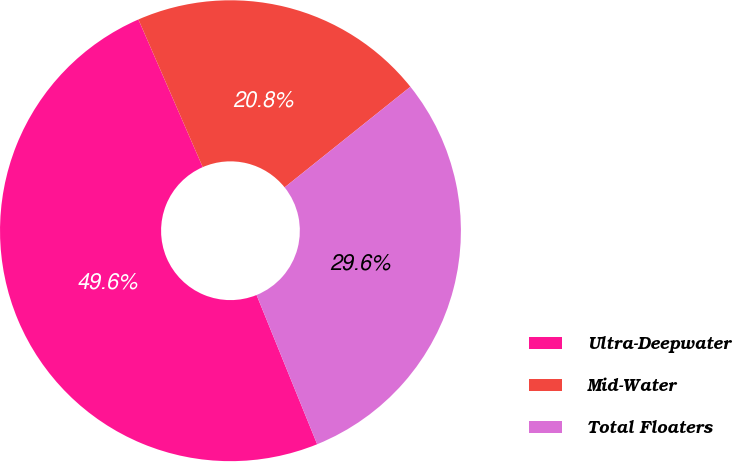Convert chart to OTSL. <chart><loc_0><loc_0><loc_500><loc_500><pie_chart><fcel>Ultra-Deepwater<fcel>Mid-Water<fcel>Total Floaters<nl><fcel>49.6%<fcel>20.8%<fcel>29.6%<nl></chart> 